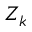Convert formula to latex. <formula><loc_0><loc_0><loc_500><loc_500>Z _ { k }</formula> 